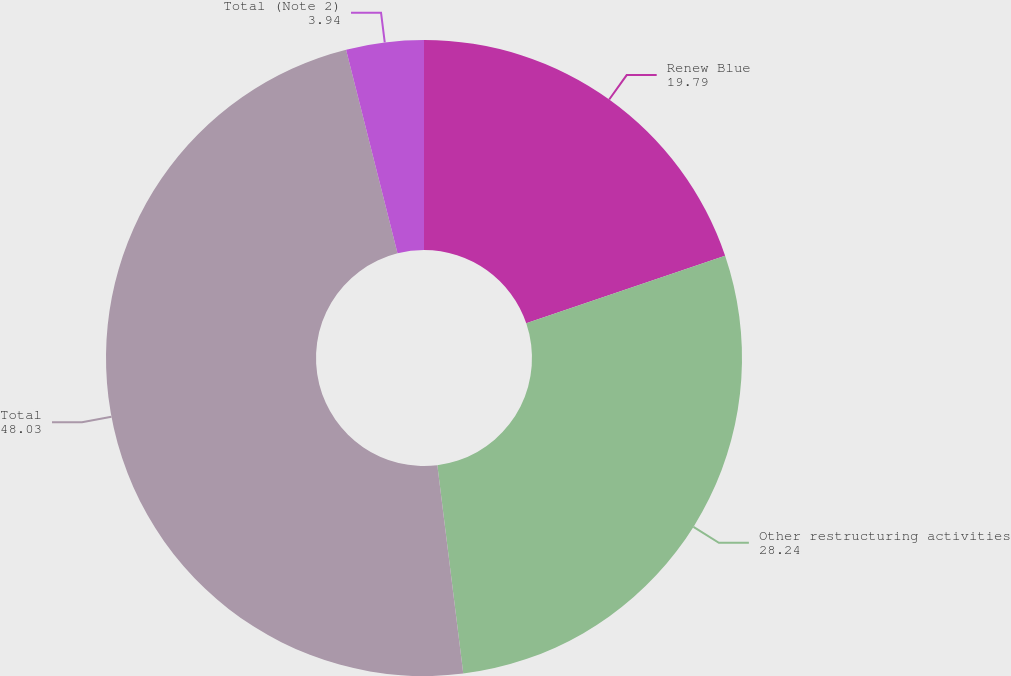Convert chart to OTSL. <chart><loc_0><loc_0><loc_500><loc_500><pie_chart><fcel>Renew Blue<fcel>Other restructuring activities<fcel>Total<fcel>Total (Note 2)<nl><fcel>19.79%<fcel>28.24%<fcel>48.03%<fcel>3.94%<nl></chart> 